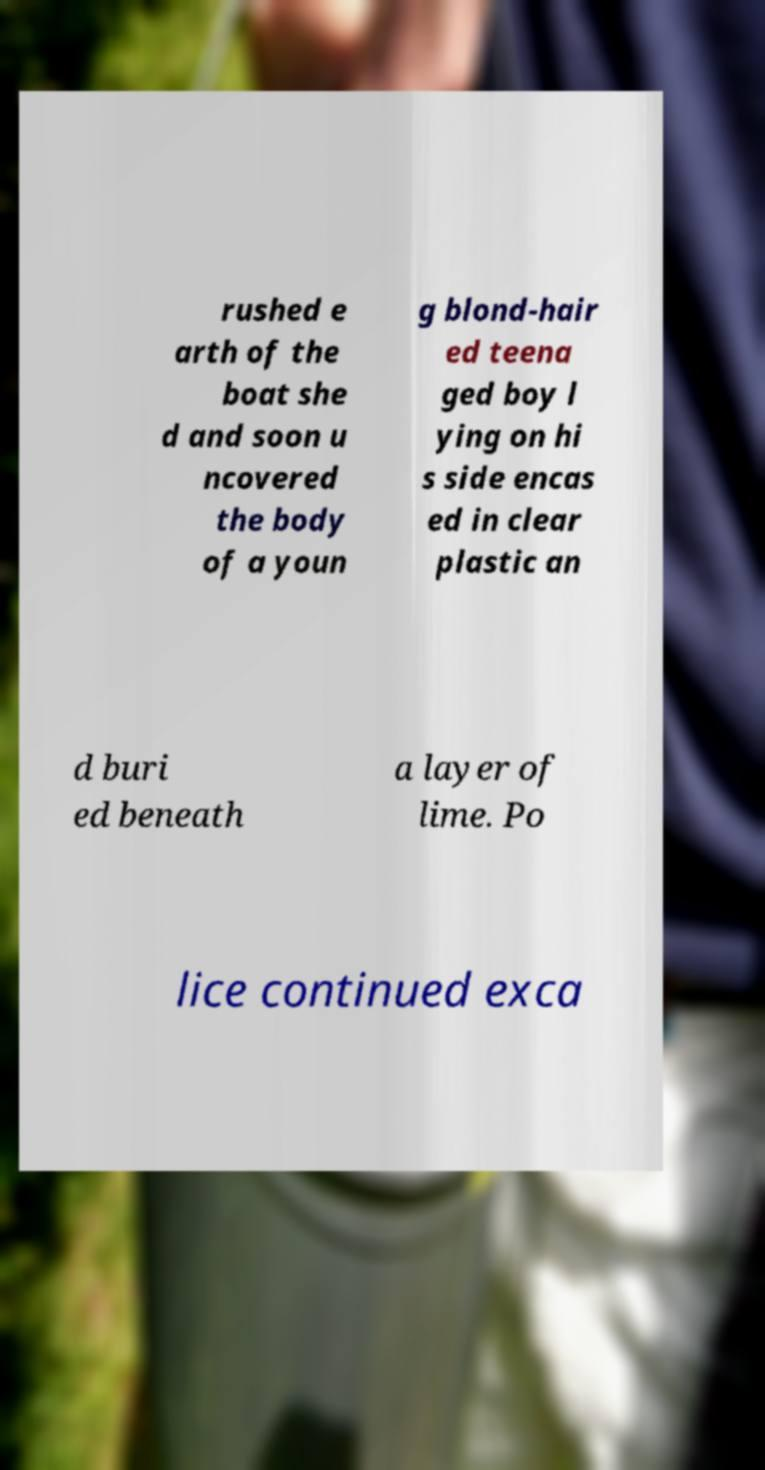For documentation purposes, I need the text within this image transcribed. Could you provide that? rushed e arth of the boat she d and soon u ncovered the body of a youn g blond-hair ed teena ged boy l ying on hi s side encas ed in clear plastic an d buri ed beneath a layer of lime. Po lice continued exca 